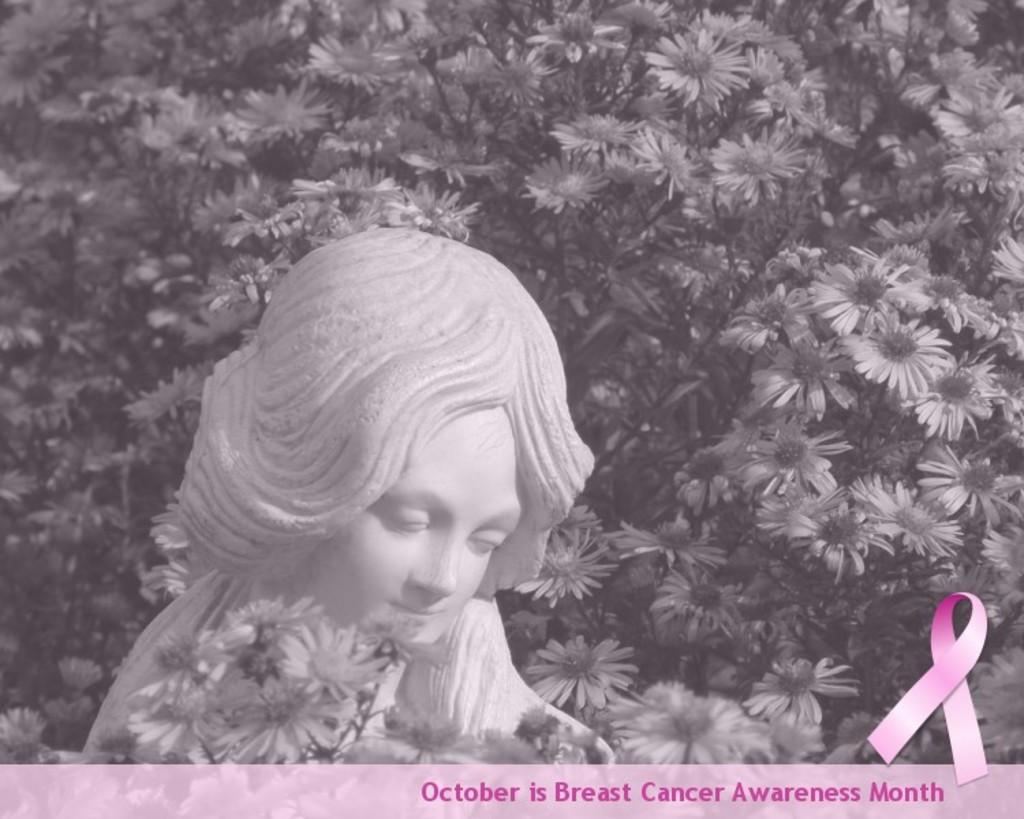What is the color scheme of the image? The image is black and white. What is the main subject in the center of the image? There is a statue in the center of the image. What can be seen in the background of the image? There are flowers in the background of the image. What type of force is being exerted by the finger on the statue in the image? There is no finger or force present in the image; it only features a statue and flowers in a black and white color scheme. 